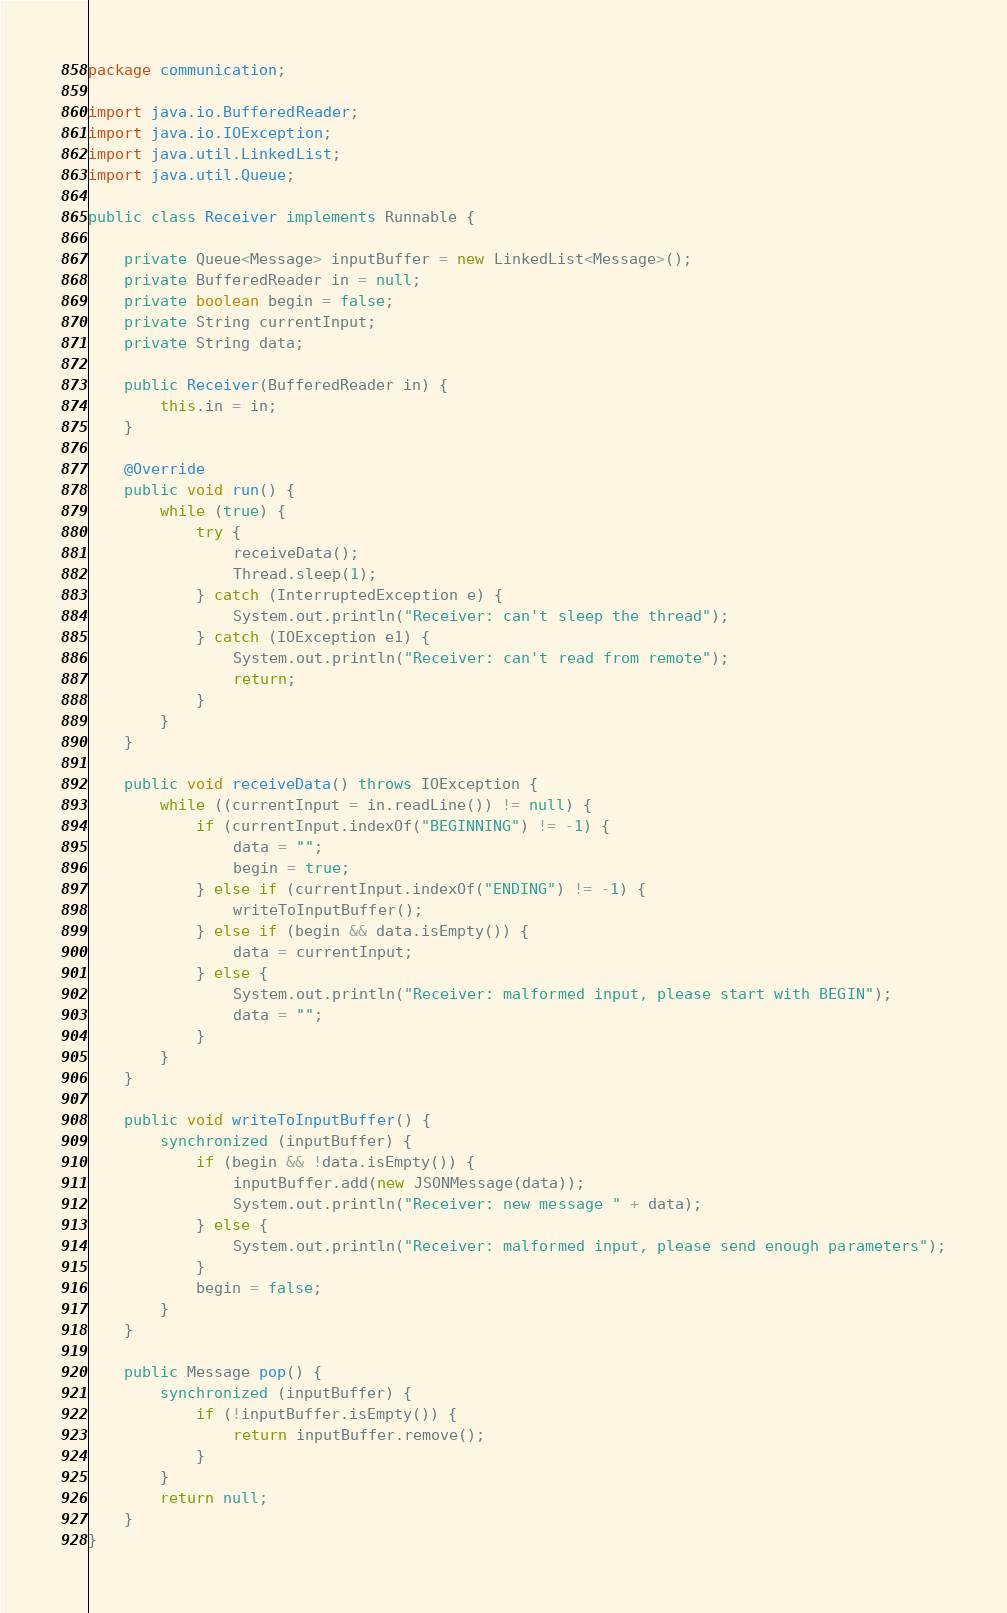<code> <loc_0><loc_0><loc_500><loc_500><_Java_>package communication;

import java.io.BufferedReader;
import java.io.IOException;
import java.util.LinkedList;
import java.util.Queue;

public class Receiver implements Runnable {

	private Queue<Message> inputBuffer = new LinkedList<Message>();
	private BufferedReader in = null;
	private boolean begin = false;
	private String currentInput;
	private String data;

	public Receiver(BufferedReader in) {
		this.in = in;
	}

	@Override
	public void run() {
		while (true) {
			try {
				receiveData();
				Thread.sleep(1);
			} catch (InterruptedException e) {
				System.out.println("Receiver: can't sleep the thread");
			} catch (IOException e1) {
				System.out.println("Receiver: can't read from remote");
				return;
			}
		}
	}

	public void receiveData() throws IOException {
		while ((currentInput = in.readLine()) != null) {
			if (currentInput.indexOf("BEGINNING") != -1) {
				data = "";
				begin = true;
			} else if (currentInput.indexOf("ENDING") != -1) {
				writeToInputBuffer();
			} else if (begin && data.isEmpty()) {
				data = currentInput;
			} else {
				System.out.println("Receiver: malformed input, please start with BEGIN");
				data = "";
			}
		}
	}

	public void writeToInputBuffer() {
		synchronized (inputBuffer) {
			if (begin && !data.isEmpty()) {
				inputBuffer.add(new JSONMessage(data));
				System.out.println("Receiver: new message " + data);
			} else {
				System.out.println("Receiver: malformed input, please send enough parameters");
			}
			begin = false;
		}
	}

	public Message pop() {
		synchronized (inputBuffer) {
			if (!inputBuffer.isEmpty()) {
				return inputBuffer.remove();
			}
		}
		return null;
	}
}
</code> 